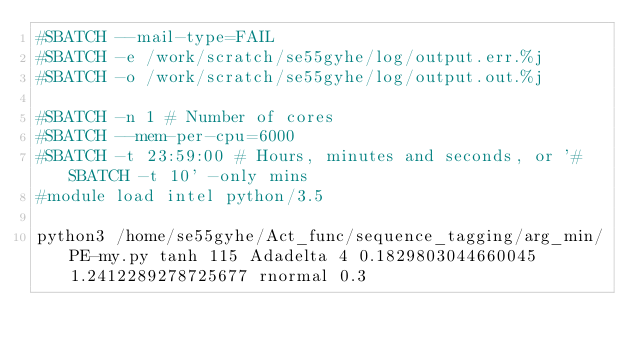<code> <loc_0><loc_0><loc_500><loc_500><_Bash_>#SBATCH --mail-type=FAIL
#SBATCH -e /work/scratch/se55gyhe/log/output.err.%j
#SBATCH -o /work/scratch/se55gyhe/log/output.out.%j

#SBATCH -n 1 # Number of cores
#SBATCH --mem-per-cpu=6000
#SBATCH -t 23:59:00 # Hours, minutes and seconds, or '#SBATCH -t 10' -only mins
#module load intel python/3.5

python3 /home/se55gyhe/Act_func/sequence_tagging/arg_min/PE-my.py tanh 115 Adadelta 4 0.1829803044660045 1.2412289278725677 rnormal 0.3

</code> 